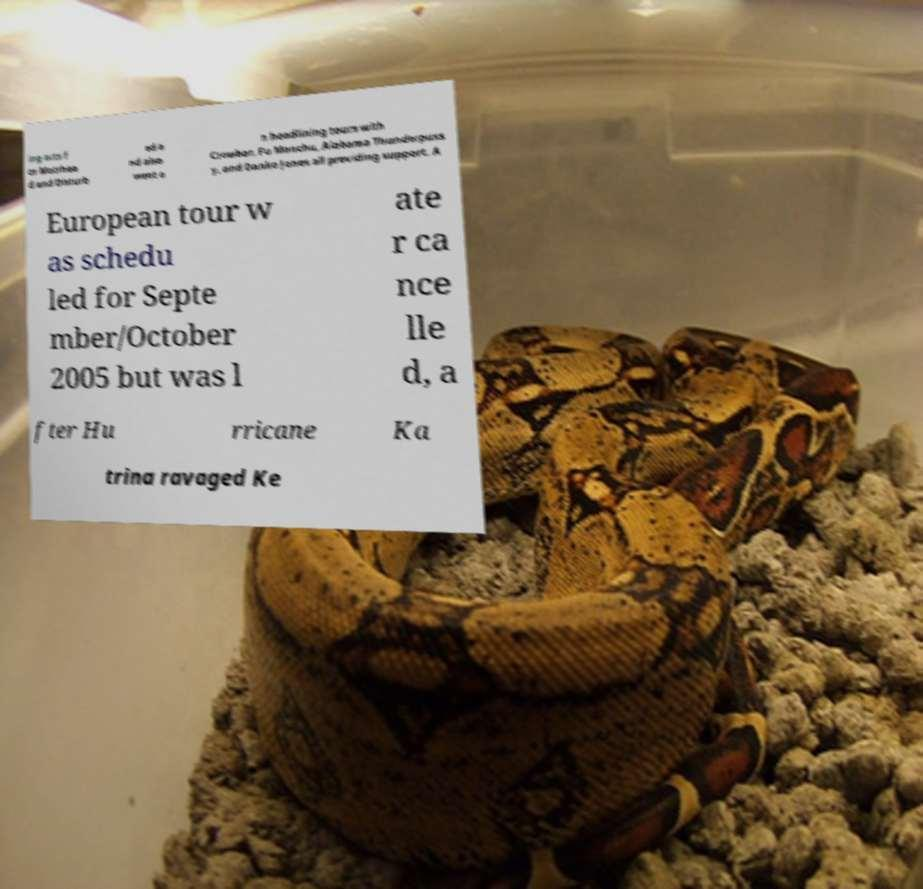Can you read and provide the text displayed in the image?This photo seems to have some interesting text. Can you extract and type it out for me? ing acts f or Motrhea d and Disturb ed a nd also went o n headlining tours with Crowbar, Fu Manchu, Alabama Thunderpuss y, and Danko Jones all providing support. A European tour w as schedu led for Septe mber/October 2005 but was l ate r ca nce lle d, a fter Hu rricane Ka trina ravaged Ke 